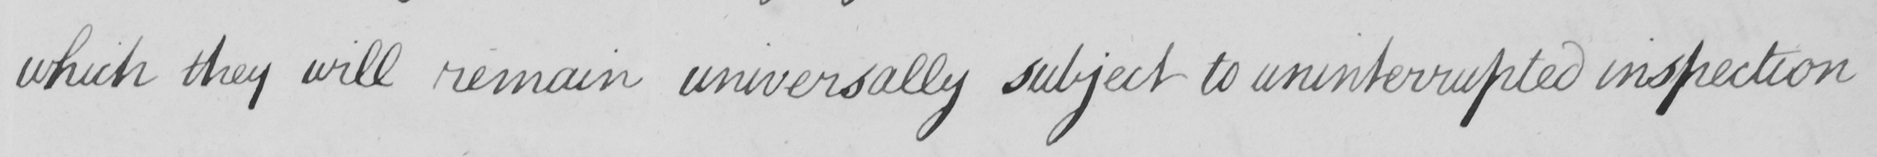Transcribe the text shown in this historical manuscript line. which they will remain universally subject to uninterrupted inspection 